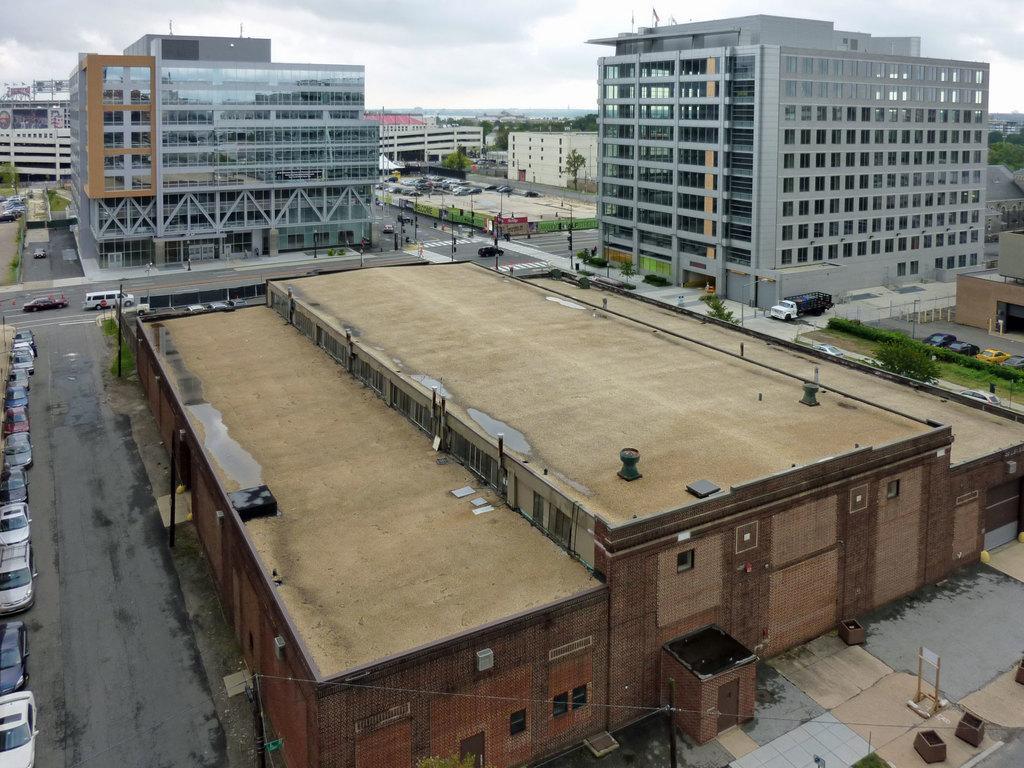Could you give a brief overview of what you see in this image? In this image I can see few buildings, vehicles. In the background I can see few trees in green color and the sky is in white color. 